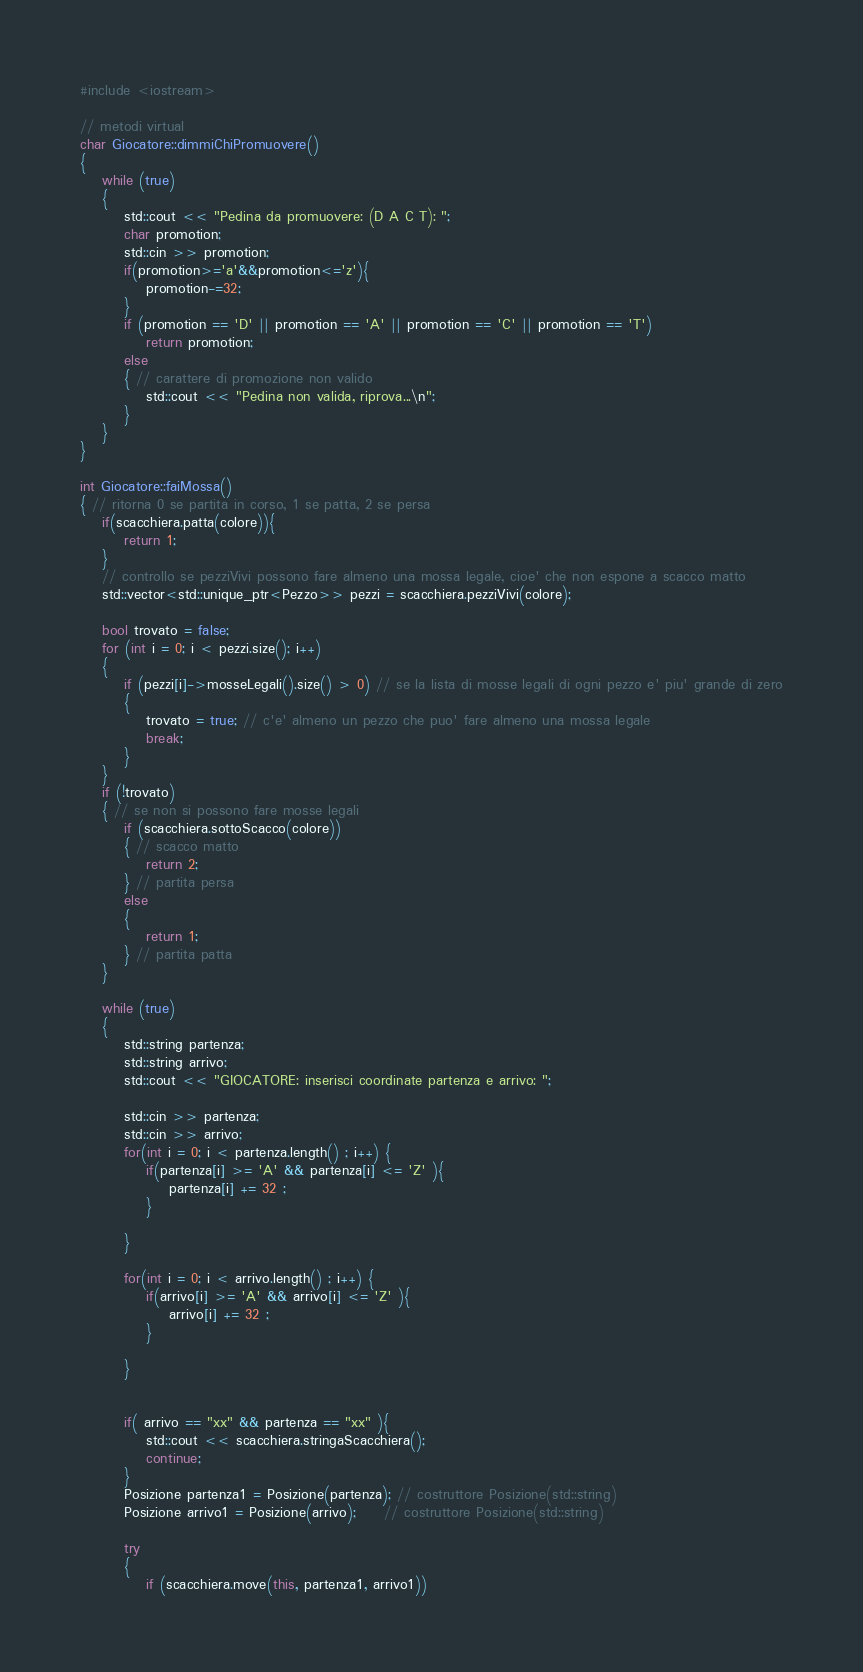<code> <loc_0><loc_0><loc_500><loc_500><_C++_>#include <iostream>

// metodi virtual
char Giocatore::dimmiChiPromuovere()
{
    while (true)
    {
        std::cout << "Pedina da promuovere: (D A C T): ";
        char promotion;
        std::cin >> promotion;
        if(promotion>='a'&&promotion<='z'){
            promotion-=32;
        }
        if (promotion == 'D' || promotion == 'A' || promotion == 'C' || promotion == 'T')
            return promotion;
        else
        { // carattere di promozione non valido
            std::cout << "Pedina non valida, riprova...\n";
        }
    }
}

int Giocatore::faiMossa()
{ // ritorna 0 se partita in corso, 1 se patta, 2 se persa
    if(scacchiera.patta(colore)){
        return 1;
    }
    // controllo se pezziVivi possono fare almeno una mossa legale, cioe' che non espone a scacco matto
    std::vector<std::unique_ptr<Pezzo>> pezzi = scacchiera.pezziVivi(colore);

    bool trovato = false;
    for (int i = 0; i < pezzi.size(); i++)
    {
        if (pezzi[i]->mosseLegali().size() > 0) // se la lista di mosse legali di ogni pezzo e' piu' grande di zero
        {
            trovato = true; // c'e' almeno un pezzo che puo' fare almeno una mossa legale
            break;
        }
    }
    if (!trovato)
    { // se non si possono fare mosse legali
        if (scacchiera.sottoScacco(colore))
        { // scacco matto
            return 2;
        } // partita persa
        else
        {
            return 1;
        } // partita patta
    }

    while (true)
    {
        std::string partenza;
        std::string arrivo;
        std::cout << "GIOCATORE: inserisci coordinate partenza e arrivo: ";
        
        std::cin >> partenza;
        std::cin >> arrivo;
        for(int i = 0; i < partenza.length() ; i++) {
            if(partenza[i] >= 'A' && partenza[i] <= 'Z' ){
                partenza[i] += 32 ;
            }

        }

        for(int i = 0; i < arrivo.length() ; i++) {
            if(arrivo[i] >= 'A' && arrivo[i] <= 'Z' ){
                arrivo[i] += 32 ;
            }

        }
        

        if( arrivo == "xx" && partenza == "xx" ){
            std::cout << scacchiera.stringaScacchiera();
            continue;
        }
        Posizione partenza1 = Posizione(partenza); // costruttore Posizione(std::string)
        Posizione arrivo1 = Posizione(arrivo);     // costruttore Posizione(std::string)

        try
        {
            if (scacchiera.move(this, partenza1, arrivo1))</code> 